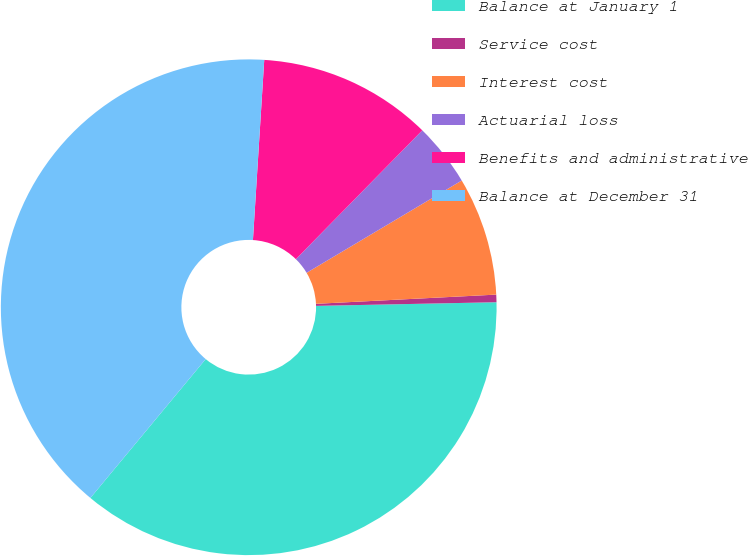Convert chart to OTSL. <chart><loc_0><loc_0><loc_500><loc_500><pie_chart><fcel>Balance at January 1<fcel>Service cost<fcel>Interest cost<fcel>Actuarial loss<fcel>Benefits and administrative<fcel>Balance at December 31<nl><fcel>36.35%<fcel>0.49%<fcel>7.73%<fcel>4.11%<fcel>11.35%<fcel>39.97%<nl></chart> 